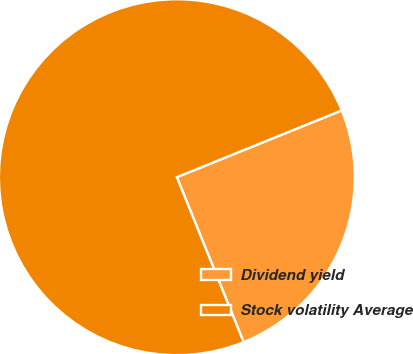Convert chart. <chart><loc_0><loc_0><loc_500><loc_500><pie_chart><fcel>Dividend yield<fcel>Stock volatility Average<nl><fcel>25.0%<fcel>75.0%<nl></chart> 